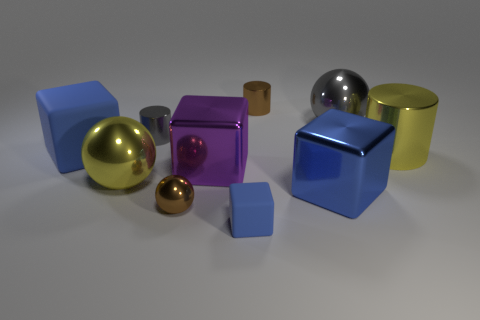Subtract all purple spheres. How many blue cubes are left? 3 Subtract 1 blocks. How many blocks are left? 3 Subtract all purple balls. Subtract all cyan cylinders. How many balls are left? 3 Subtract all cubes. How many objects are left? 6 Subtract all tiny brown shiny cylinders. Subtract all big cylinders. How many objects are left? 8 Add 5 gray metal cylinders. How many gray metal cylinders are left? 6 Add 5 big yellow metallic blocks. How many big yellow metallic blocks exist? 5 Subtract 1 gray cylinders. How many objects are left? 9 